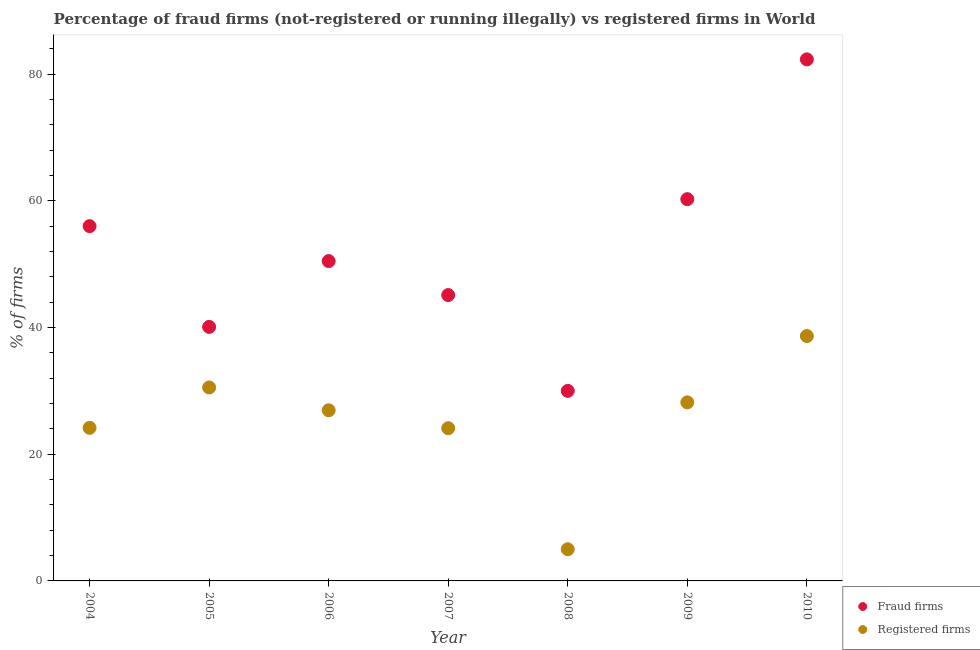How many different coloured dotlines are there?
Provide a short and direct response. 2. What is the percentage of fraud firms in 2004?
Keep it short and to the point. 56.01. Across all years, what is the maximum percentage of fraud firms?
Your answer should be compact. 82.33. In which year was the percentage of fraud firms maximum?
Provide a succinct answer. 2010. In which year was the percentage of registered firms minimum?
Keep it short and to the point. 2008. What is the total percentage of fraud firms in the graph?
Your answer should be compact. 364.31. What is the difference between the percentage of registered firms in 2006 and that in 2008?
Your response must be concise. 21.94. What is the difference between the percentage of registered firms in 2007 and the percentage of fraud firms in 2008?
Provide a succinct answer. -5.89. What is the average percentage of fraud firms per year?
Keep it short and to the point. 52.04. In the year 2004, what is the difference between the percentage of registered firms and percentage of fraud firms?
Your response must be concise. -31.84. In how many years, is the percentage of registered firms greater than 44 %?
Ensure brevity in your answer.  0. What is the ratio of the percentage of fraud firms in 2005 to that in 2007?
Your answer should be compact. 0.89. Is the difference between the percentage of registered firms in 2004 and 2006 greater than the difference between the percentage of fraud firms in 2004 and 2006?
Provide a succinct answer. No. What is the difference between the highest and the second highest percentage of registered firms?
Keep it short and to the point. 8.12. What is the difference between the highest and the lowest percentage of fraud firms?
Give a very brief answer. 52.33. In how many years, is the percentage of registered firms greater than the average percentage of registered firms taken over all years?
Offer a very short reply. 4. Does the percentage of registered firms monotonically increase over the years?
Offer a terse response. No. Is the percentage of fraud firms strictly less than the percentage of registered firms over the years?
Offer a very short reply. No. How many years are there in the graph?
Your answer should be very brief. 7. What is the difference between two consecutive major ticks on the Y-axis?
Your answer should be compact. 20. Are the values on the major ticks of Y-axis written in scientific E-notation?
Provide a short and direct response. No. Does the graph contain grids?
Your answer should be compact. No. Where does the legend appear in the graph?
Offer a very short reply. Bottom right. How are the legend labels stacked?
Ensure brevity in your answer.  Vertical. What is the title of the graph?
Provide a succinct answer. Percentage of fraud firms (not-registered or running illegally) vs registered firms in World. What is the label or title of the X-axis?
Make the answer very short. Year. What is the label or title of the Y-axis?
Offer a terse response. % of firms. What is the % of firms of Fraud firms in 2004?
Provide a succinct answer. 56.01. What is the % of firms in Registered firms in 2004?
Provide a succinct answer. 24.17. What is the % of firms of Fraud firms in 2005?
Your answer should be very brief. 40.1. What is the % of firms of Registered firms in 2005?
Give a very brief answer. 30.54. What is the % of firms in Fraud firms in 2006?
Keep it short and to the point. 50.49. What is the % of firms of Registered firms in 2006?
Ensure brevity in your answer.  26.94. What is the % of firms of Fraud firms in 2007?
Make the answer very short. 45.12. What is the % of firms in Registered firms in 2007?
Your answer should be compact. 24.11. What is the % of firms in Fraud firms in 2008?
Your answer should be compact. 30. What is the % of firms in Registered firms in 2008?
Your answer should be very brief. 5. What is the % of firms in Fraud firms in 2009?
Ensure brevity in your answer.  60.26. What is the % of firms in Registered firms in 2009?
Your response must be concise. 28.19. What is the % of firms in Fraud firms in 2010?
Offer a very short reply. 82.33. What is the % of firms of Registered firms in 2010?
Make the answer very short. 38.66. Across all years, what is the maximum % of firms in Fraud firms?
Your answer should be very brief. 82.33. Across all years, what is the maximum % of firms in Registered firms?
Provide a short and direct response. 38.66. What is the total % of firms in Fraud firms in the graph?
Your answer should be compact. 364.31. What is the total % of firms of Registered firms in the graph?
Provide a short and direct response. 177.6. What is the difference between the % of firms of Fraud firms in 2004 and that in 2005?
Provide a succinct answer. 15.91. What is the difference between the % of firms in Registered firms in 2004 and that in 2005?
Keep it short and to the point. -6.37. What is the difference between the % of firms of Fraud firms in 2004 and that in 2006?
Provide a succinct answer. 5.52. What is the difference between the % of firms of Registered firms in 2004 and that in 2006?
Make the answer very short. -2.77. What is the difference between the % of firms in Fraud firms in 2004 and that in 2007?
Make the answer very short. 10.88. What is the difference between the % of firms in Registered firms in 2004 and that in 2007?
Your answer should be compact. 0.06. What is the difference between the % of firms of Fraud firms in 2004 and that in 2008?
Make the answer very short. 26. What is the difference between the % of firms in Registered firms in 2004 and that in 2008?
Offer a terse response. 19.17. What is the difference between the % of firms in Fraud firms in 2004 and that in 2009?
Keep it short and to the point. -4.26. What is the difference between the % of firms of Registered firms in 2004 and that in 2009?
Give a very brief answer. -4.02. What is the difference between the % of firms in Fraud firms in 2004 and that in 2010?
Offer a terse response. -26.32. What is the difference between the % of firms of Registered firms in 2004 and that in 2010?
Provide a short and direct response. -14.49. What is the difference between the % of firms in Fraud firms in 2005 and that in 2006?
Make the answer very short. -10.39. What is the difference between the % of firms of Registered firms in 2005 and that in 2006?
Your answer should be very brief. 3.6. What is the difference between the % of firms of Fraud firms in 2005 and that in 2007?
Offer a terse response. -5.02. What is the difference between the % of firms of Registered firms in 2005 and that in 2007?
Make the answer very short. 6.43. What is the difference between the % of firms in Fraud firms in 2005 and that in 2008?
Give a very brief answer. 10.1. What is the difference between the % of firms of Registered firms in 2005 and that in 2008?
Offer a terse response. 25.54. What is the difference between the % of firms in Fraud firms in 2005 and that in 2009?
Your answer should be compact. -20.16. What is the difference between the % of firms in Registered firms in 2005 and that in 2009?
Offer a terse response. 2.35. What is the difference between the % of firms of Fraud firms in 2005 and that in 2010?
Your answer should be very brief. -42.23. What is the difference between the % of firms in Registered firms in 2005 and that in 2010?
Your response must be concise. -8.12. What is the difference between the % of firms in Fraud firms in 2006 and that in 2007?
Make the answer very short. 5.36. What is the difference between the % of firms of Registered firms in 2006 and that in 2007?
Make the answer very short. 2.83. What is the difference between the % of firms of Fraud firms in 2006 and that in 2008?
Make the answer very short. 20.49. What is the difference between the % of firms of Registered firms in 2006 and that in 2008?
Your response must be concise. 21.94. What is the difference between the % of firms in Fraud firms in 2006 and that in 2009?
Ensure brevity in your answer.  -9.78. What is the difference between the % of firms in Registered firms in 2006 and that in 2009?
Give a very brief answer. -1.25. What is the difference between the % of firms in Fraud firms in 2006 and that in 2010?
Your answer should be very brief. -31.84. What is the difference between the % of firms in Registered firms in 2006 and that in 2010?
Make the answer very short. -11.72. What is the difference between the % of firms in Fraud firms in 2007 and that in 2008?
Provide a succinct answer. 15.12. What is the difference between the % of firms in Registered firms in 2007 and that in 2008?
Offer a very short reply. 19.11. What is the difference between the % of firms in Fraud firms in 2007 and that in 2009?
Your response must be concise. -15.14. What is the difference between the % of firms of Registered firms in 2007 and that in 2009?
Your response must be concise. -4.08. What is the difference between the % of firms in Fraud firms in 2007 and that in 2010?
Ensure brevity in your answer.  -37.21. What is the difference between the % of firms of Registered firms in 2007 and that in 2010?
Keep it short and to the point. -14.55. What is the difference between the % of firms of Fraud firms in 2008 and that in 2009?
Keep it short and to the point. -30.26. What is the difference between the % of firms in Registered firms in 2008 and that in 2009?
Offer a terse response. -23.19. What is the difference between the % of firms of Fraud firms in 2008 and that in 2010?
Provide a short and direct response. -52.33. What is the difference between the % of firms of Registered firms in 2008 and that in 2010?
Provide a succinct answer. -33.66. What is the difference between the % of firms in Fraud firms in 2009 and that in 2010?
Make the answer very short. -22.07. What is the difference between the % of firms of Registered firms in 2009 and that in 2010?
Provide a succinct answer. -10.47. What is the difference between the % of firms in Fraud firms in 2004 and the % of firms in Registered firms in 2005?
Provide a short and direct response. 25.47. What is the difference between the % of firms of Fraud firms in 2004 and the % of firms of Registered firms in 2006?
Provide a short and direct response. 29.06. What is the difference between the % of firms of Fraud firms in 2004 and the % of firms of Registered firms in 2007?
Give a very brief answer. 31.9. What is the difference between the % of firms of Fraud firms in 2004 and the % of firms of Registered firms in 2008?
Provide a succinct answer. 51.01. What is the difference between the % of firms in Fraud firms in 2004 and the % of firms in Registered firms in 2009?
Ensure brevity in your answer.  27.82. What is the difference between the % of firms of Fraud firms in 2004 and the % of firms of Registered firms in 2010?
Your answer should be very brief. 17.35. What is the difference between the % of firms of Fraud firms in 2005 and the % of firms of Registered firms in 2006?
Ensure brevity in your answer.  13.16. What is the difference between the % of firms in Fraud firms in 2005 and the % of firms in Registered firms in 2007?
Offer a very short reply. 15.99. What is the difference between the % of firms in Fraud firms in 2005 and the % of firms in Registered firms in 2008?
Provide a succinct answer. 35.1. What is the difference between the % of firms of Fraud firms in 2005 and the % of firms of Registered firms in 2009?
Your answer should be compact. 11.91. What is the difference between the % of firms in Fraud firms in 2005 and the % of firms in Registered firms in 2010?
Give a very brief answer. 1.44. What is the difference between the % of firms in Fraud firms in 2006 and the % of firms in Registered firms in 2007?
Offer a very short reply. 26.38. What is the difference between the % of firms of Fraud firms in 2006 and the % of firms of Registered firms in 2008?
Make the answer very short. 45.49. What is the difference between the % of firms of Fraud firms in 2006 and the % of firms of Registered firms in 2009?
Your answer should be very brief. 22.3. What is the difference between the % of firms in Fraud firms in 2006 and the % of firms in Registered firms in 2010?
Ensure brevity in your answer.  11.83. What is the difference between the % of firms in Fraud firms in 2007 and the % of firms in Registered firms in 2008?
Keep it short and to the point. 40.12. What is the difference between the % of firms of Fraud firms in 2007 and the % of firms of Registered firms in 2009?
Make the answer very short. 16.94. What is the difference between the % of firms of Fraud firms in 2007 and the % of firms of Registered firms in 2010?
Provide a succinct answer. 6.47. What is the difference between the % of firms in Fraud firms in 2008 and the % of firms in Registered firms in 2009?
Your answer should be compact. 1.81. What is the difference between the % of firms of Fraud firms in 2008 and the % of firms of Registered firms in 2010?
Keep it short and to the point. -8.66. What is the difference between the % of firms in Fraud firms in 2009 and the % of firms in Registered firms in 2010?
Your answer should be very brief. 21.6. What is the average % of firms in Fraud firms per year?
Offer a terse response. 52.04. What is the average % of firms of Registered firms per year?
Your answer should be compact. 25.37. In the year 2004, what is the difference between the % of firms in Fraud firms and % of firms in Registered firms?
Offer a terse response. 31.84. In the year 2005, what is the difference between the % of firms in Fraud firms and % of firms in Registered firms?
Offer a very short reply. 9.56. In the year 2006, what is the difference between the % of firms of Fraud firms and % of firms of Registered firms?
Provide a short and direct response. 23.55. In the year 2007, what is the difference between the % of firms in Fraud firms and % of firms in Registered firms?
Offer a very short reply. 21.02. In the year 2008, what is the difference between the % of firms in Fraud firms and % of firms in Registered firms?
Your answer should be very brief. 25. In the year 2009, what is the difference between the % of firms of Fraud firms and % of firms of Registered firms?
Your answer should be very brief. 32.07. In the year 2010, what is the difference between the % of firms in Fraud firms and % of firms in Registered firms?
Offer a very short reply. 43.67. What is the ratio of the % of firms of Fraud firms in 2004 to that in 2005?
Make the answer very short. 1.4. What is the ratio of the % of firms of Registered firms in 2004 to that in 2005?
Your answer should be compact. 0.79. What is the ratio of the % of firms in Fraud firms in 2004 to that in 2006?
Your answer should be very brief. 1.11. What is the ratio of the % of firms in Registered firms in 2004 to that in 2006?
Make the answer very short. 0.9. What is the ratio of the % of firms of Fraud firms in 2004 to that in 2007?
Your answer should be compact. 1.24. What is the ratio of the % of firms in Fraud firms in 2004 to that in 2008?
Keep it short and to the point. 1.87. What is the ratio of the % of firms in Registered firms in 2004 to that in 2008?
Offer a terse response. 4.83. What is the ratio of the % of firms of Fraud firms in 2004 to that in 2009?
Offer a terse response. 0.93. What is the ratio of the % of firms of Registered firms in 2004 to that in 2009?
Offer a very short reply. 0.86. What is the ratio of the % of firms in Fraud firms in 2004 to that in 2010?
Offer a very short reply. 0.68. What is the ratio of the % of firms in Registered firms in 2004 to that in 2010?
Your response must be concise. 0.63. What is the ratio of the % of firms in Fraud firms in 2005 to that in 2006?
Your answer should be very brief. 0.79. What is the ratio of the % of firms in Registered firms in 2005 to that in 2006?
Give a very brief answer. 1.13. What is the ratio of the % of firms in Fraud firms in 2005 to that in 2007?
Ensure brevity in your answer.  0.89. What is the ratio of the % of firms in Registered firms in 2005 to that in 2007?
Your answer should be compact. 1.27. What is the ratio of the % of firms of Fraud firms in 2005 to that in 2008?
Ensure brevity in your answer.  1.34. What is the ratio of the % of firms in Registered firms in 2005 to that in 2008?
Offer a terse response. 6.11. What is the ratio of the % of firms of Fraud firms in 2005 to that in 2009?
Provide a short and direct response. 0.67. What is the ratio of the % of firms in Registered firms in 2005 to that in 2009?
Provide a short and direct response. 1.08. What is the ratio of the % of firms of Fraud firms in 2005 to that in 2010?
Offer a very short reply. 0.49. What is the ratio of the % of firms of Registered firms in 2005 to that in 2010?
Ensure brevity in your answer.  0.79. What is the ratio of the % of firms of Fraud firms in 2006 to that in 2007?
Your answer should be compact. 1.12. What is the ratio of the % of firms of Registered firms in 2006 to that in 2007?
Offer a terse response. 1.12. What is the ratio of the % of firms in Fraud firms in 2006 to that in 2008?
Your answer should be very brief. 1.68. What is the ratio of the % of firms in Registered firms in 2006 to that in 2008?
Your answer should be compact. 5.39. What is the ratio of the % of firms in Fraud firms in 2006 to that in 2009?
Your answer should be very brief. 0.84. What is the ratio of the % of firms of Registered firms in 2006 to that in 2009?
Give a very brief answer. 0.96. What is the ratio of the % of firms in Fraud firms in 2006 to that in 2010?
Provide a short and direct response. 0.61. What is the ratio of the % of firms in Registered firms in 2006 to that in 2010?
Ensure brevity in your answer.  0.7. What is the ratio of the % of firms in Fraud firms in 2007 to that in 2008?
Your answer should be compact. 1.5. What is the ratio of the % of firms of Registered firms in 2007 to that in 2008?
Your answer should be very brief. 4.82. What is the ratio of the % of firms of Fraud firms in 2007 to that in 2009?
Give a very brief answer. 0.75. What is the ratio of the % of firms of Registered firms in 2007 to that in 2009?
Make the answer very short. 0.86. What is the ratio of the % of firms in Fraud firms in 2007 to that in 2010?
Make the answer very short. 0.55. What is the ratio of the % of firms of Registered firms in 2007 to that in 2010?
Give a very brief answer. 0.62. What is the ratio of the % of firms in Fraud firms in 2008 to that in 2009?
Give a very brief answer. 0.5. What is the ratio of the % of firms in Registered firms in 2008 to that in 2009?
Make the answer very short. 0.18. What is the ratio of the % of firms in Fraud firms in 2008 to that in 2010?
Provide a short and direct response. 0.36. What is the ratio of the % of firms in Registered firms in 2008 to that in 2010?
Give a very brief answer. 0.13. What is the ratio of the % of firms of Fraud firms in 2009 to that in 2010?
Offer a terse response. 0.73. What is the ratio of the % of firms of Registered firms in 2009 to that in 2010?
Your answer should be very brief. 0.73. What is the difference between the highest and the second highest % of firms of Fraud firms?
Your answer should be compact. 22.07. What is the difference between the highest and the second highest % of firms of Registered firms?
Provide a short and direct response. 8.12. What is the difference between the highest and the lowest % of firms of Fraud firms?
Make the answer very short. 52.33. What is the difference between the highest and the lowest % of firms in Registered firms?
Keep it short and to the point. 33.66. 